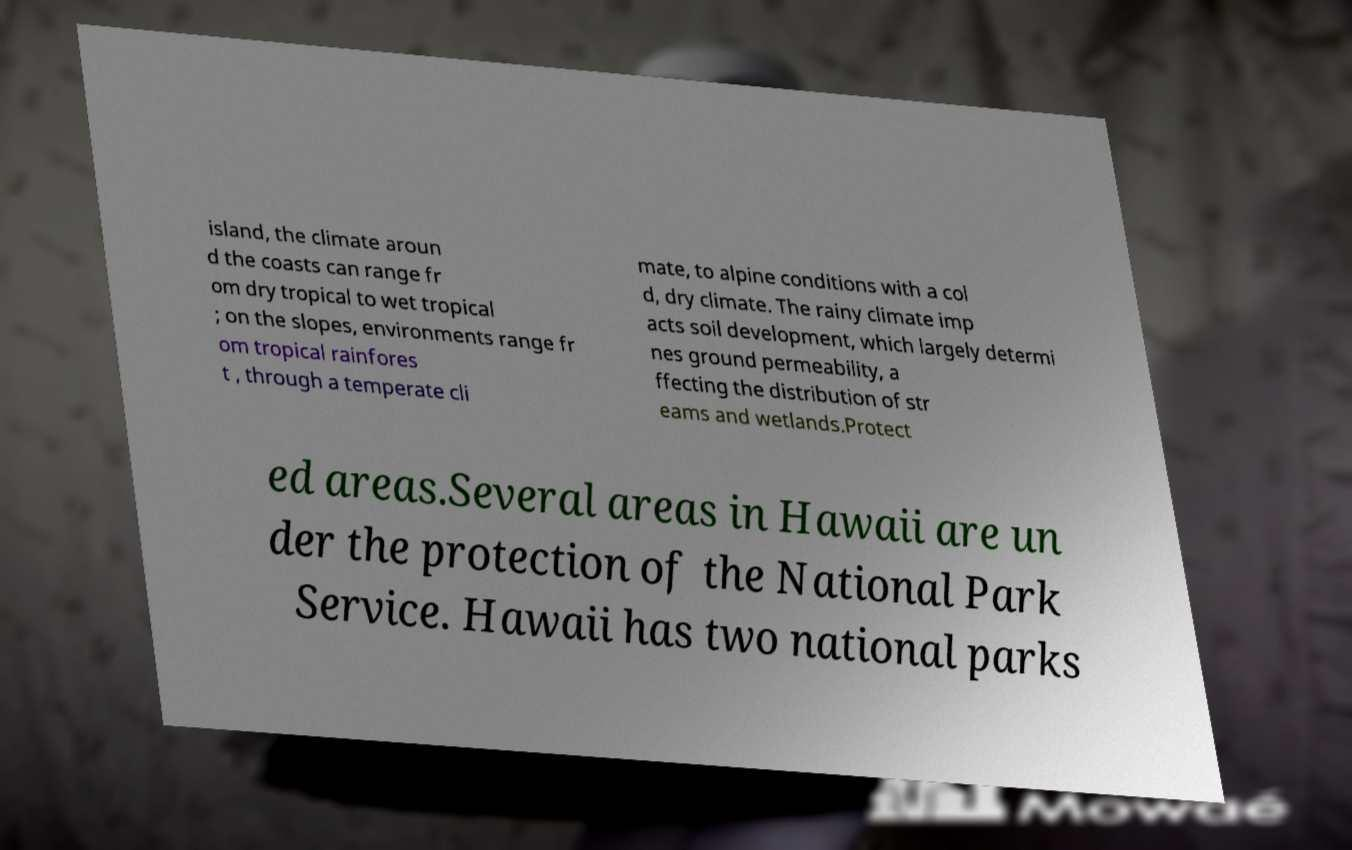Please identify and transcribe the text found in this image. island, the climate aroun d the coasts can range fr om dry tropical to wet tropical ; on the slopes, environments range fr om tropical rainfores t , through a temperate cli mate, to alpine conditions with a col d, dry climate. The rainy climate imp acts soil development, which largely determi nes ground permeability, a ffecting the distribution of str eams and wetlands.Protect ed areas.Several areas in Hawaii are un der the protection of the National Park Service. Hawaii has two national parks 